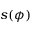Convert formula to latex. <formula><loc_0><loc_0><loc_500><loc_500>s ( \phi )</formula> 